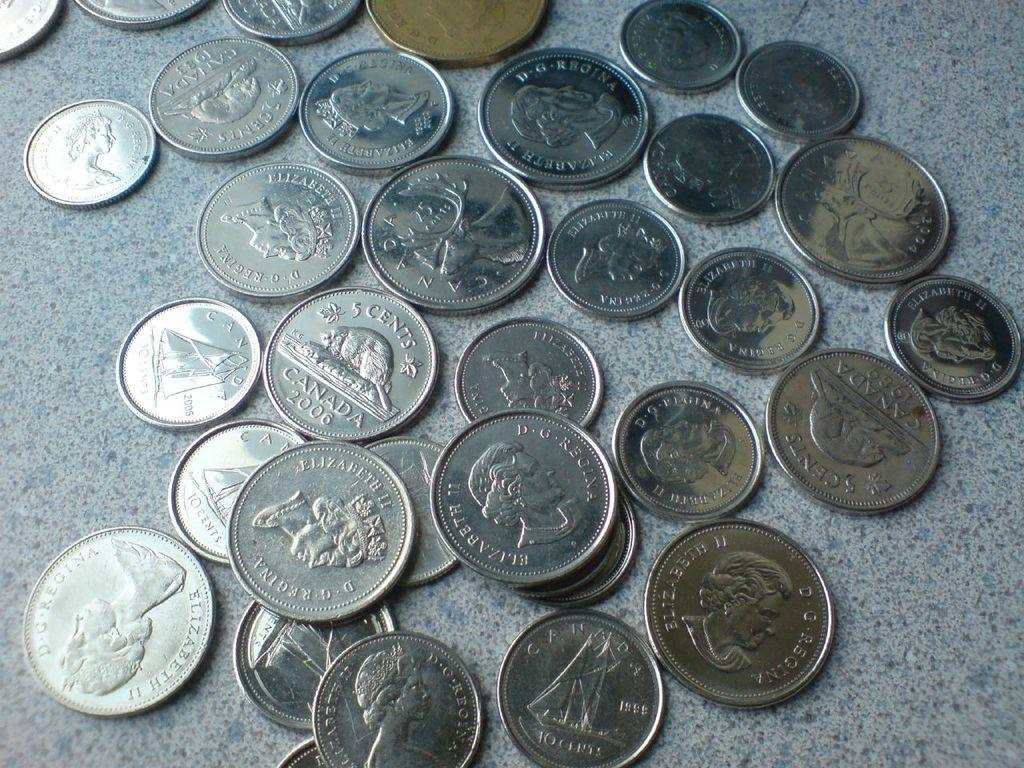<image>
Present a compact description of the photo's key features. Many coins that say D.G. Regina are sitting on a table. 